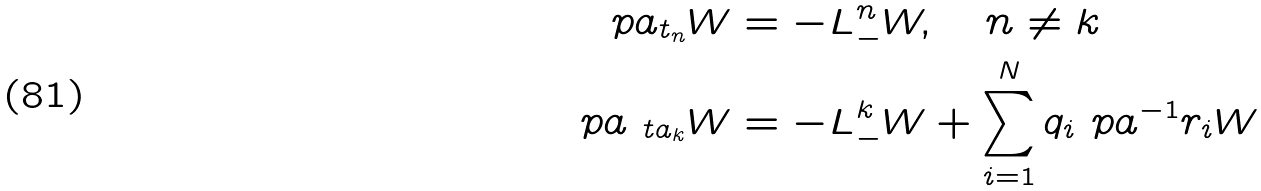<formula> <loc_0><loc_0><loc_500><loc_500>\ p a _ { t _ { n } } W & = - L ^ { n } _ { - } W , \quad n \neq k \\ \ p a _ { \ t a _ { k } } W & = - L ^ { k } _ { - } W + \sum _ { i = 1 } ^ { N } q _ { i } \ p a ^ { - 1 } r _ { i } W</formula> 